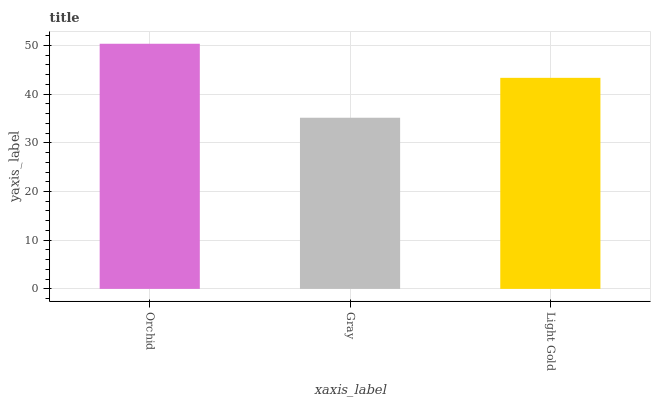Is Gray the minimum?
Answer yes or no. Yes. Is Orchid the maximum?
Answer yes or no. Yes. Is Light Gold the minimum?
Answer yes or no. No. Is Light Gold the maximum?
Answer yes or no. No. Is Light Gold greater than Gray?
Answer yes or no. Yes. Is Gray less than Light Gold?
Answer yes or no. Yes. Is Gray greater than Light Gold?
Answer yes or no. No. Is Light Gold less than Gray?
Answer yes or no. No. Is Light Gold the high median?
Answer yes or no. Yes. Is Light Gold the low median?
Answer yes or no. Yes. Is Gray the high median?
Answer yes or no. No. Is Gray the low median?
Answer yes or no. No. 